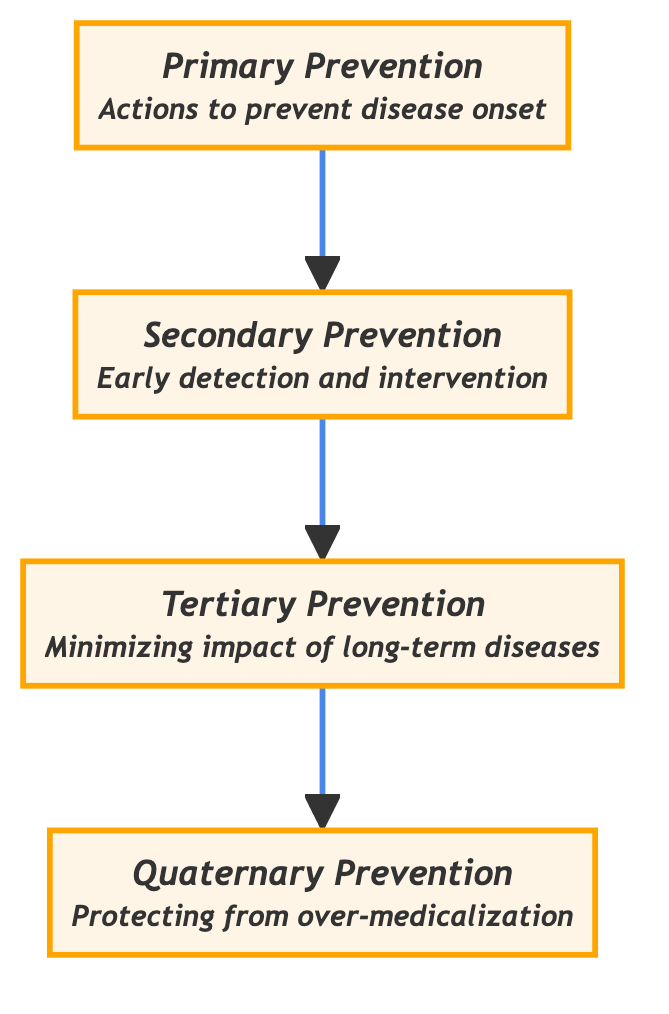What is the top level in the hierarchy? The diagram shows a clear hierarchy with Quaternary Prevention at the top level. This is determined by following the upward direction of the flow chart, where Quaternary Prevention is positioned above all other measures.
Answer: Quaternary Prevention How many levels are there in the hierarchy? Counting the nodes in the diagram, there are four distinct levels: Primary, Secondary, Tertiary, and Quaternary Prevention. Each of these corresponds to a step in the preventive medicine measures.
Answer: Four What is the purpose of Tertiary Prevention? The description in the diagram specifies that Tertiary Prevention is focused on minimizing the impact of long-term diseases and injuries. This is the stated function of this measure as illustrated in the node for Tertiary Prevention.
Answer: Minimizing impact of long-term diseases Which level comes after Secondary Prevention? The flow of the diagram indicates that Tertiary Prevention follows directly after Secondary Prevention, since there is an arrow pointing from Secondary to Tertiary in an upward direction.
Answer: Tertiary Prevention What type of prevention includes vaccinations? The diagram identifies Primary Prevention as the level responsible for actions like vaccinations. This is detailed in the description for Primary Prevention, which specifically mentions such actions as part of its purpose.
Answer: Primary Prevention How does Quaternary Prevention aim to protect patients? Quaternary Prevention aims to protect patients by identifying those at risk of over-medicalization and suggesting ethically acceptable interventions. This is encapsulated in its description within the diagram, which outlines its specific objectives.
Answer: Protect from over-medicalization What is the relationship between Primary and Secondary Prevention? The relationship is sequential, where Primary Prevention is the foundational level that leads directly to Secondary Prevention. This is evident from the diagram's upward flow, where one level progresses to the next.
Answer: Primary leads to Secondary What activities are included in Secondary Prevention? According to the diagram, activities such as regular health check-ups and screening tests are included in Secondary Prevention. This is mentioned in the description associated with that level, confirming all associated interventions.
Answer: Regular health check-ups What does the arrow direction indicate about the hierarchy? The upward direction of the arrows indicates a progression from foundational measures (Primary Prevention) to more complex and specific measures (Quaternary Prevention), reflecting increasing levels of intervention.
Answer: A progression of measures 